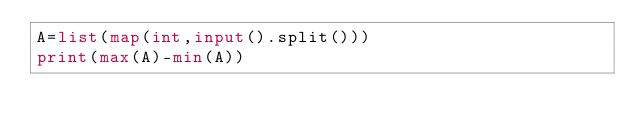Convert code to text. <code><loc_0><loc_0><loc_500><loc_500><_Python_>A=list(map(int,input().split()))
print(max(A)-min(A))</code> 